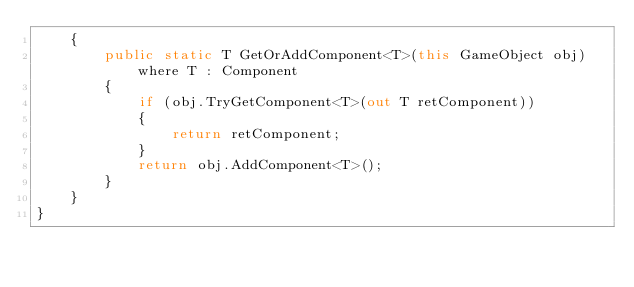<code> <loc_0><loc_0><loc_500><loc_500><_C#_>    {
        public static T GetOrAddComponent<T>(this GameObject obj) where T : Component
        {
            if (obj.TryGetComponent<T>(out T retComponent))
            {
                return retComponent;
            }
            return obj.AddComponent<T>();
        }
    }
}</code> 